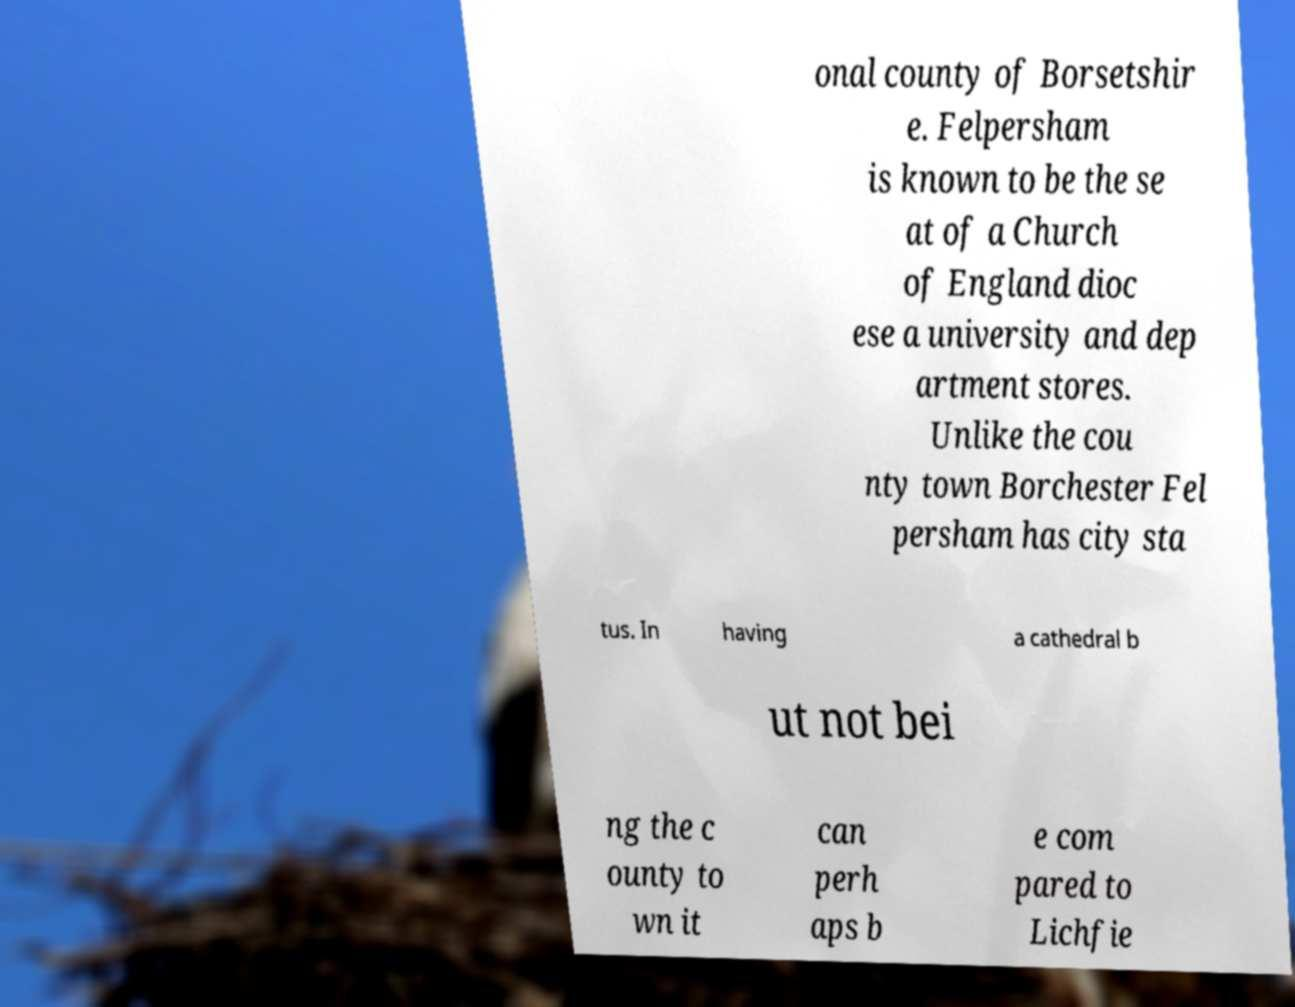Can you read and provide the text displayed in the image?This photo seems to have some interesting text. Can you extract and type it out for me? onal county of Borsetshir e. Felpersham is known to be the se at of a Church of England dioc ese a university and dep artment stores. Unlike the cou nty town Borchester Fel persham has city sta tus. In having a cathedral b ut not bei ng the c ounty to wn it can perh aps b e com pared to Lichfie 